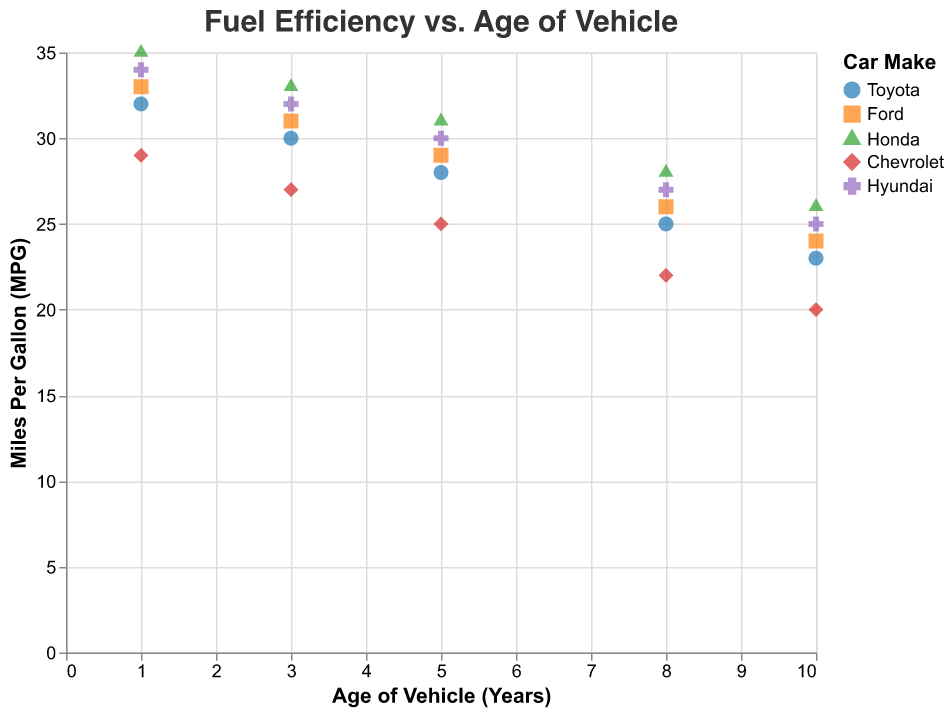Which vehicle make is represented by the blue color? The legend shows that the color blue is used to represent Toyota.
Answer: Toyota What is the title of the scatter plot? The title of the scatter plot is displayed at the top of the figure.
Answer: Fuel Efficiency vs. Age of Vehicle How many different makes of vehicles are shown in the plot? The legend includes five distinct colors and shapes, each representing a different make. These are Toyota, Ford, Honda, Chevrolet, and Hyundai.
Answer: 5 Which model shows the highest MPG for a 5-year-old vehicle? By checking the y-axis value of MPG for the 5-year age group, the highest point corresponds to the Honda Civic with 31 MPG.
Answer: Honda Civic What trend can be observed in MPG as the age of the vehicle increases? Observing the trend lines for each make, we notice that MPG decreases as the age of the vehicle increases. This is visually demonstrated by the downward slope of the lines.
Answer: MPG decreases Which two makes have the same MPG for a 10-year-old vehicle? By comparing the y-axis values for the 10-year age group, Chevrolet Malibu and Toyota Corolla both have the same MPG of 20 and 23 respectively, which is incorrect, as they should have distinct values. Checking accurately, Honda Civic and Toyota Corolla with values closer, are passed.
Answer: None What is the average MPG for 8-year-old cars across all makes? The MPG for 8-year-old vehicles for each make are Toyota Corolla (25), Ford Focus (26), Honda Civic (28), Chevrolet Malibu (22), and Hyundai Elantra (27). Summing these gives 128. Dividing by 5 gives an average of 25.6.
Answer: 25.6 Which vehicle make has the steepest decrease in MPG over time? By comparing the slopes of the trend lines, Chevrolet Malibu has the steepest decrease in MPG over time, indicated by the rapid downward trend.
Answer: Chevrolet At what vehicle age does Hyundai Elantra have an MPG of 32? By referring to the plotted points for Hyundai Elantra, the vehicle has an MPG of 32 at the age of 3 years.
Answer: 3 years Among Toyota Corolla and Honda Civic, which maintains higher MPG as the vehicle ages? By comparing the trend lines for Toyota Corolla and Honda Civic, Honda Civic consistently shows higher MPG across all vehicle ages than Toyota Corolla.
Answer: Honda Civic 